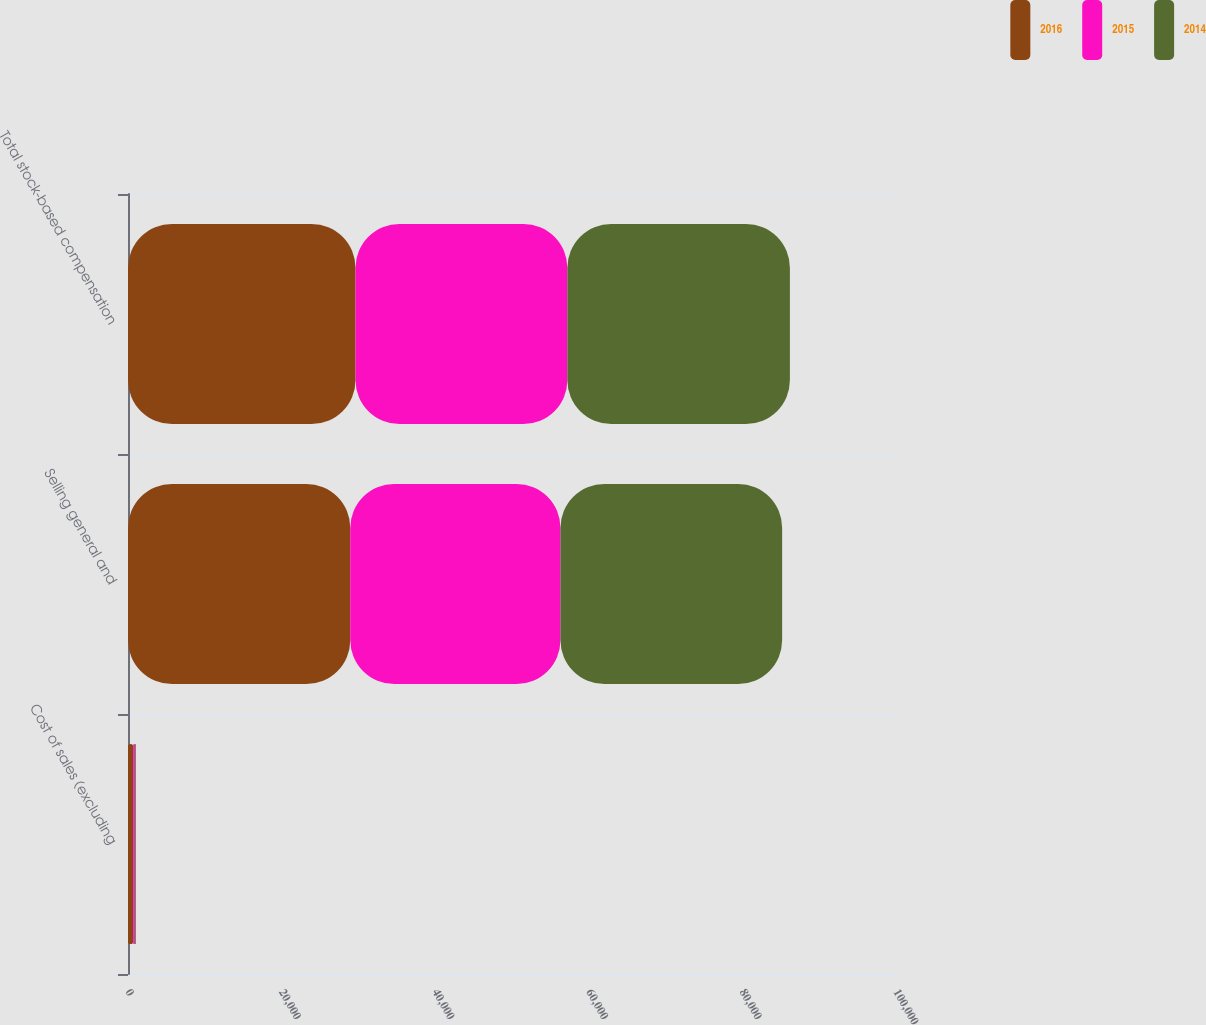Convert chart to OTSL. <chart><loc_0><loc_0><loc_500><loc_500><stacked_bar_chart><ecel><fcel>Cost of sales (excluding<fcel>Selling general and<fcel>Total stock-based compensation<nl><fcel>2016<fcel>680<fcel>28944<fcel>29624<nl><fcel>2015<fcel>220<fcel>27365<fcel>27585<nl><fcel>2014<fcel>110<fcel>28866<fcel>28976<nl></chart> 